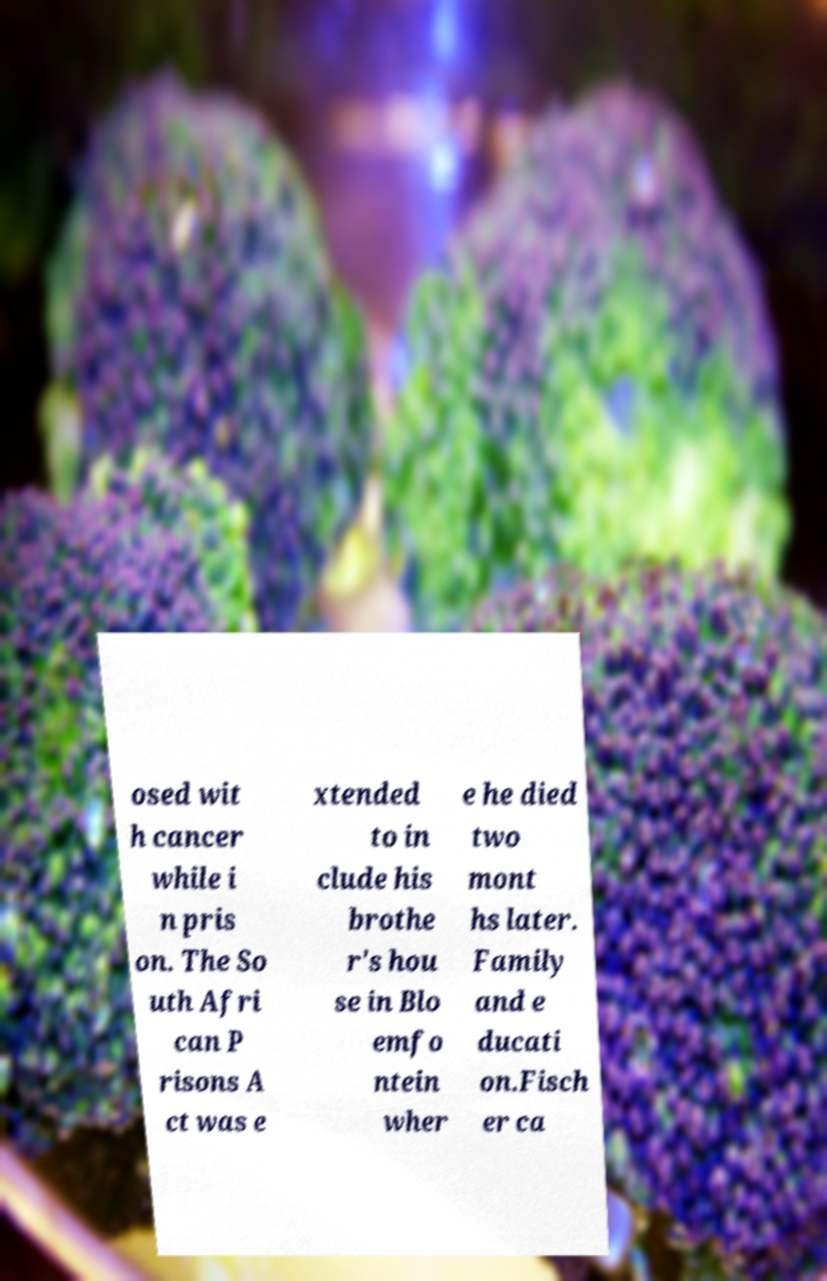There's text embedded in this image that I need extracted. Can you transcribe it verbatim? osed wit h cancer while i n pris on. The So uth Afri can P risons A ct was e xtended to in clude his brothe r's hou se in Blo emfo ntein wher e he died two mont hs later. Family and e ducati on.Fisch er ca 